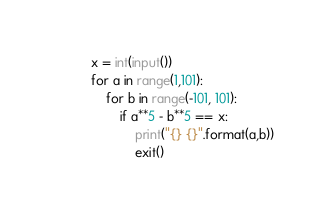Convert code to text. <code><loc_0><loc_0><loc_500><loc_500><_Python_>x = int(input())
for a in range(1,101):
    for b in range(-101, 101):
        if a**5 - b**5 == x:
            print("{} {}".format(a,b))
            exit()
</code> 